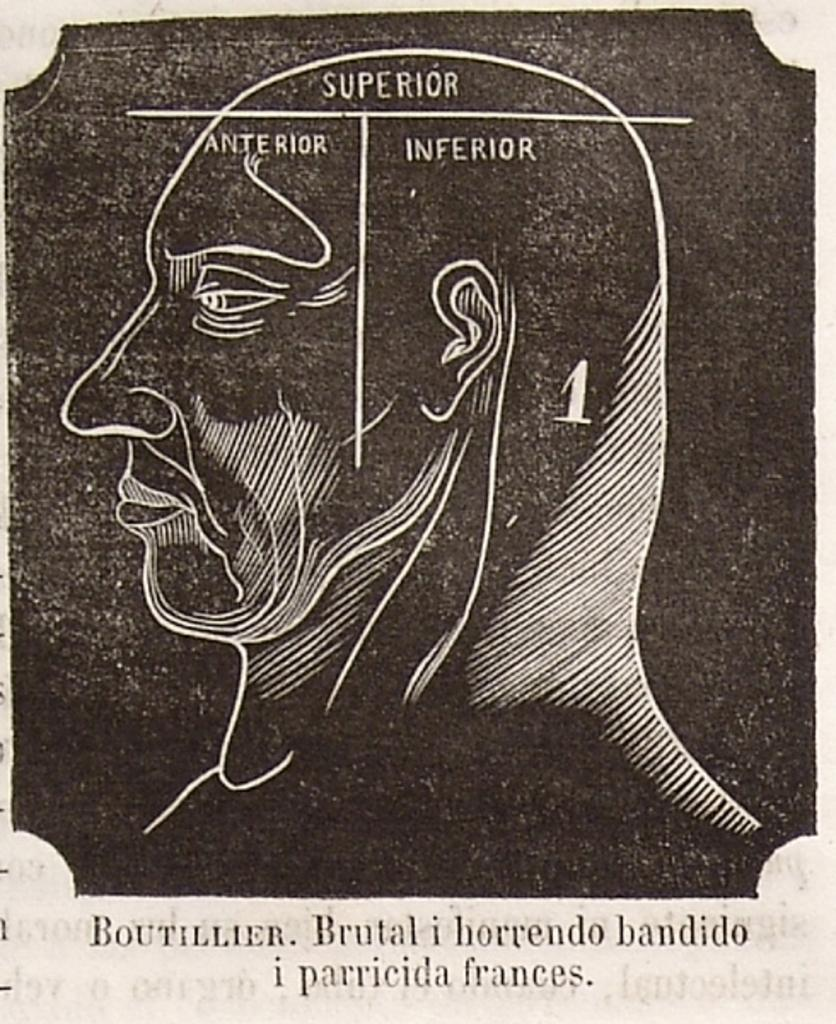What is the main subject of the image? The main subject of the image is a poster. What is depicted on the poster? The poster has an outline of a human face. What type of information is on the poster? The matter is written on the poster. What color scheme is used in the image? The image is in black and white color. Can you tell me how many zippers are on the poster? There are no zippers present on the poster; it features an outline of a human face and written matter. What is the purpose of the poster in the image? The purpose of the poster cannot be determined from the image alone, as it lacks context. 